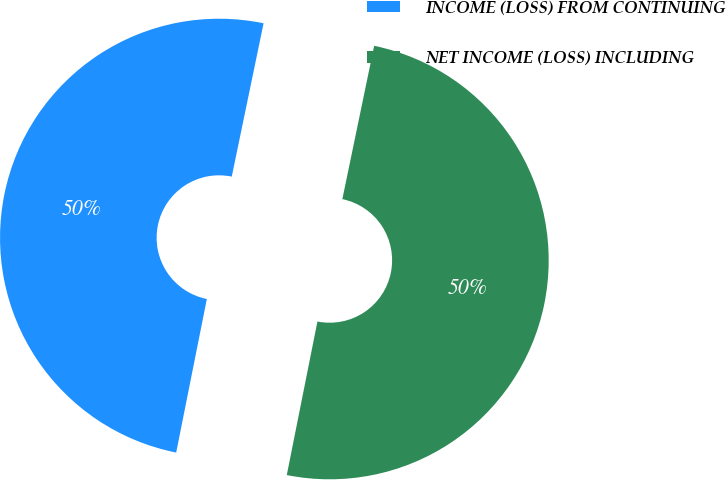<chart> <loc_0><loc_0><loc_500><loc_500><pie_chart><fcel>INCOME (LOSS) FROM CONTINUING<fcel>NET INCOME (LOSS) INCLUDING<nl><fcel>50.12%<fcel>49.88%<nl></chart> 